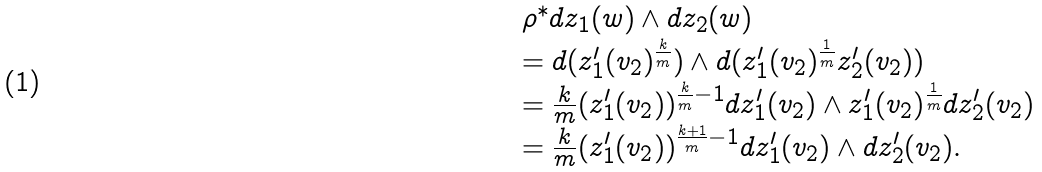<formula> <loc_0><loc_0><loc_500><loc_500>\begin{array} { l } \rho ^ { \ast } d z _ { 1 } ( w ) \wedge d z _ { 2 } ( w ) \\ = d ( z _ { 1 } ^ { \prime } ( v _ { 2 } ) ^ { \frac { k } { m } } ) \wedge d ( z _ { 1 } ^ { \prime } ( v _ { 2 } ) ^ { \frac { 1 } { m } } z _ { 2 } ^ { \prime } ( v _ { 2 } ) ) \\ = \frac { k } { m } ( z _ { 1 } ^ { \prime } ( v _ { 2 } ) ) ^ { \frac { k } { m } - 1 } d z _ { 1 } ^ { \prime } ( v _ { 2 } ) \wedge z _ { 1 } ^ { \prime } ( v _ { 2 } ) ^ { \frac { 1 } { m } } d z _ { 2 } ^ { \prime } ( v _ { 2 } ) \\ = \frac { k } { m } ( z _ { 1 } ^ { \prime } ( v _ { 2 } ) ) ^ { \frac { k + 1 } { m } - 1 } d z _ { 1 } ^ { \prime } ( v _ { 2 } ) \wedge d z _ { 2 } ^ { \prime } ( v _ { 2 } ) . \end{array}</formula> 